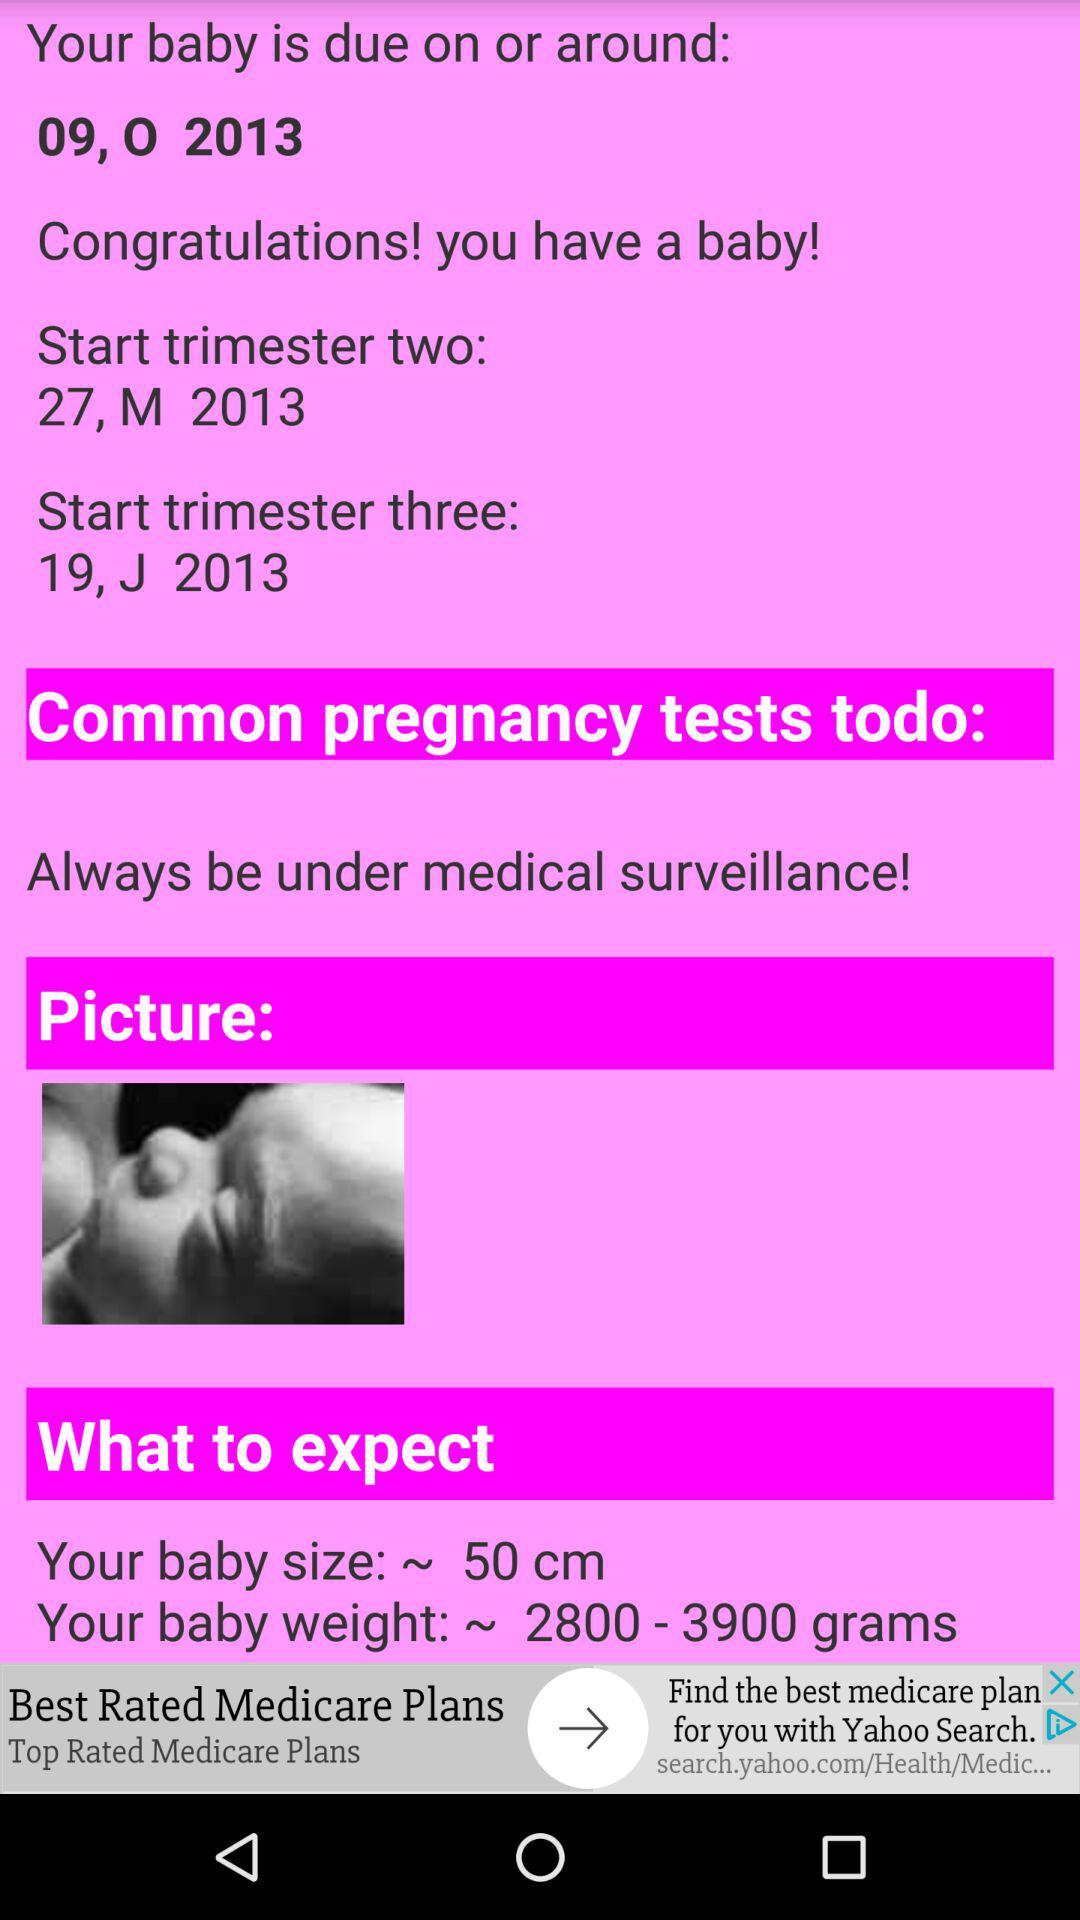What is the name of the application?
When the provided information is insufficient, respond with <no answer>. <no answer> 